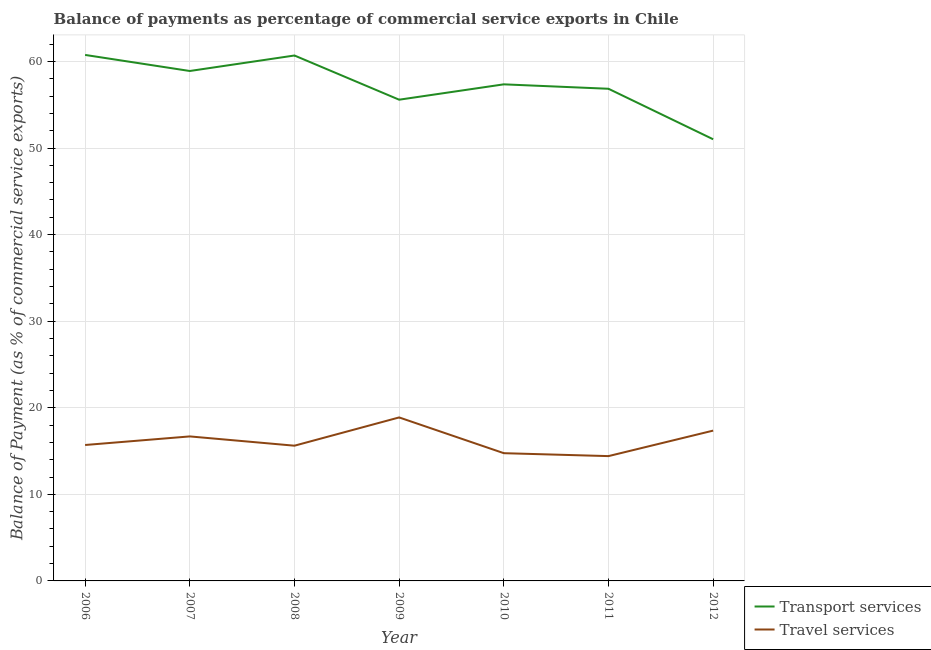What is the balance of payments of travel services in 2007?
Your answer should be very brief. 16.69. Across all years, what is the maximum balance of payments of travel services?
Provide a short and direct response. 18.88. Across all years, what is the minimum balance of payments of travel services?
Your response must be concise. 14.42. What is the total balance of payments of travel services in the graph?
Keep it short and to the point. 113.42. What is the difference between the balance of payments of travel services in 2006 and that in 2010?
Your response must be concise. 0.95. What is the difference between the balance of payments of transport services in 2007 and the balance of payments of travel services in 2009?
Your answer should be very brief. 40.01. What is the average balance of payments of travel services per year?
Keep it short and to the point. 16.2. In the year 2011, what is the difference between the balance of payments of travel services and balance of payments of transport services?
Offer a very short reply. -42.43. What is the ratio of the balance of payments of transport services in 2008 to that in 2011?
Offer a very short reply. 1.07. What is the difference between the highest and the second highest balance of payments of transport services?
Your answer should be compact. 0.07. What is the difference between the highest and the lowest balance of payments of transport services?
Offer a very short reply. 9.74. In how many years, is the balance of payments of travel services greater than the average balance of payments of travel services taken over all years?
Provide a short and direct response. 3. Is the sum of the balance of payments of transport services in 2008 and 2011 greater than the maximum balance of payments of travel services across all years?
Offer a very short reply. Yes. Does the balance of payments of transport services monotonically increase over the years?
Give a very brief answer. No. Does the graph contain grids?
Your response must be concise. Yes. Where does the legend appear in the graph?
Keep it short and to the point. Bottom right. How many legend labels are there?
Your answer should be very brief. 2. What is the title of the graph?
Provide a succinct answer. Balance of payments as percentage of commercial service exports in Chile. Does "Private creditors" appear as one of the legend labels in the graph?
Your answer should be very brief. No. What is the label or title of the Y-axis?
Your answer should be compact. Balance of Payment (as % of commercial service exports). What is the Balance of Payment (as % of commercial service exports) of Transport services in 2006?
Keep it short and to the point. 60.75. What is the Balance of Payment (as % of commercial service exports) of Travel services in 2006?
Provide a succinct answer. 15.7. What is the Balance of Payment (as % of commercial service exports) in Transport services in 2007?
Offer a terse response. 58.9. What is the Balance of Payment (as % of commercial service exports) of Travel services in 2007?
Your answer should be very brief. 16.69. What is the Balance of Payment (as % of commercial service exports) in Transport services in 2008?
Keep it short and to the point. 60.69. What is the Balance of Payment (as % of commercial service exports) of Travel services in 2008?
Your answer should be very brief. 15.62. What is the Balance of Payment (as % of commercial service exports) of Transport services in 2009?
Offer a very short reply. 55.58. What is the Balance of Payment (as % of commercial service exports) in Travel services in 2009?
Ensure brevity in your answer.  18.88. What is the Balance of Payment (as % of commercial service exports) of Transport services in 2010?
Offer a very short reply. 57.36. What is the Balance of Payment (as % of commercial service exports) of Travel services in 2010?
Make the answer very short. 14.75. What is the Balance of Payment (as % of commercial service exports) in Transport services in 2011?
Provide a succinct answer. 56.84. What is the Balance of Payment (as % of commercial service exports) of Travel services in 2011?
Make the answer very short. 14.42. What is the Balance of Payment (as % of commercial service exports) of Transport services in 2012?
Give a very brief answer. 51.01. What is the Balance of Payment (as % of commercial service exports) of Travel services in 2012?
Keep it short and to the point. 17.36. Across all years, what is the maximum Balance of Payment (as % of commercial service exports) of Transport services?
Offer a terse response. 60.75. Across all years, what is the maximum Balance of Payment (as % of commercial service exports) of Travel services?
Ensure brevity in your answer.  18.88. Across all years, what is the minimum Balance of Payment (as % of commercial service exports) of Transport services?
Ensure brevity in your answer.  51.01. Across all years, what is the minimum Balance of Payment (as % of commercial service exports) in Travel services?
Offer a terse response. 14.42. What is the total Balance of Payment (as % of commercial service exports) in Transport services in the graph?
Provide a succinct answer. 401.13. What is the total Balance of Payment (as % of commercial service exports) in Travel services in the graph?
Make the answer very short. 113.42. What is the difference between the Balance of Payment (as % of commercial service exports) of Transport services in 2006 and that in 2007?
Provide a short and direct response. 1.85. What is the difference between the Balance of Payment (as % of commercial service exports) in Travel services in 2006 and that in 2007?
Your answer should be compact. -0.99. What is the difference between the Balance of Payment (as % of commercial service exports) of Transport services in 2006 and that in 2008?
Provide a succinct answer. 0.07. What is the difference between the Balance of Payment (as % of commercial service exports) in Travel services in 2006 and that in 2008?
Offer a very short reply. 0.08. What is the difference between the Balance of Payment (as % of commercial service exports) in Transport services in 2006 and that in 2009?
Provide a short and direct response. 5.17. What is the difference between the Balance of Payment (as % of commercial service exports) of Travel services in 2006 and that in 2009?
Offer a very short reply. -3.18. What is the difference between the Balance of Payment (as % of commercial service exports) of Transport services in 2006 and that in 2010?
Ensure brevity in your answer.  3.4. What is the difference between the Balance of Payment (as % of commercial service exports) of Travel services in 2006 and that in 2010?
Keep it short and to the point. 0.95. What is the difference between the Balance of Payment (as % of commercial service exports) of Transport services in 2006 and that in 2011?
Ensure brevity in your answer.  3.91. What is the difference between the Balance of Payment (as % of commercial service exports) in Travel services in 2006 and that in 2011?
Ensure brevity in your answer.  1.28. What is the difference between the Balance of Payment (as % of commercial service exports) of Transport services in 2006 and that in 2012?
Your answer should be very brief. 9.74. What is the difference between the Balance of Payment (as % of commercial service exports) in Travel services in 2006 and that in 2012?
Your answer should be compact. -1.66. What is the difference between the Balance of Payment (as % of commercial service exports) in Transport services in 2007 and that in 2008?
Your answer should be very brief. -1.79. What is the difference between the Balance of Payment (as % of commercial service exports) of Travel services in 2007 and that in 2008?
Provide a succinct answer. 1.07. What is the difference between the Balance of Payment (as % of commercial service exports) in Transport services in 2007 and that in 2009?
Ensure brevity in your answer.  3.32. What is the difference between the Balance of Payment (as % of commercial service exports) in Travel services in 2007 and that in 2009?
Your answer should be very brief. -2.19. What is the difference between the Balance of Payment (as % of commercial service exports) in Transport services in 2007 and that in 2010?
Your answer should be compact. 1.54. What is the difference between the Balance of Payment (as % of commercial service exports) in Travel services in 2007 and that in 2010?
Ensure brevity in your answer.  1.94. What is the difference between the Balance of Payment (as % of commercial service exports) in Transport services in 2007 and that in 2011?
Provide a short and direct response. 2.05. What is the difference between the Balance of Payment (as % of commercial service exports) of Travel services in 2007 and that in 2011?
Your response must be concise. 2.27. What is the difference between the Balance of Payment (as % of commercial service exports) of Transport services in 2007 and that in 2012?
Make the answer very short. 7.89. What is the difference between the Balance of Payment (as % of commercial service exports) in Travel services in 2007 and that in 2012?
Ensure brevity in your answer.  -0.67. What is the difference between the Balance of Payment (as % of commercial service exports) of Transport services in 2008 and that in 2009?
Your answer should be very brief. 5.1. What is the difference between the Balance of Payment (as % of commercial service exports) of Travel services in 2008 and that in 2009?
Give a very brief answer. -3.26. What is the difference between the Balance of Payment (as % of commercial service exports) of Transport services in 2008 and that in 2010?
Make the answer very short. 3.33. What is the difference between the Balance of Payment (as % of commercial service exports) of Travel services in 2008 and that in 2010?
Make the answer very short. 0.87. What is the difference between the Balance of Payment (as % of commercial service exports) in Transport services in 2008 and that in 2011?
Provide a short and direct response. 3.84. What is the difference between the Balance of Payment (as % of commercial service exports) of Travel services in 2008 and that in 2011?
Provide a short and direct response. 1.2. What is the difference between the Balance of Payment (as % of commercial service exports) of Transport services in 2008 and that in 2012?
Give a very brief answer. 9.68. What is the difference between the Balance of Payment (as % of commercial service exports) of Travel services in 2008 and that in 2012?
Give a very brief answer. -1.74. What is the difference between the Balance of Payment (as % of commercial service exports) in Transport services in 2009 and that in 2010?
Make the answer very short. -1.77. What is the difference between the Balance of Payment (as % of commercial service exports) in Travel services in 2009 and that in 2010?
Ensure brevity in your answer.  4.13. What is the difference between the Balance of Payment (as % of commercial service exports) of Transport services in 2009 and that in 2011?
Keep it short and to the point. -1.26. What is the difference between the Balance of Payment (as % of commercial service exports) in Travel services in 2009 and that in 2011?
Offer a very short reply. 4.47. What is the difference between the Balance of Payment (as % of commercial service exports) in Transport services in 2009 and that in 2012?
Offer a terse response. 4.57. What is the difference between the Balance of Payment (as % of commercial service exports) in Travel services in 2009 and that in 2012?
Your answer should be compact. 1.52. What is the difference between the Balance of Payment (as % of commercial service exports) of Transport services in 2010 and that in 2011?
Your answer should be very brief. 0.51. What is the difference between the Balance of Payment (as % of commercial service exports) in Travel services in 2010 and that in 2011?
Make the answer very short. 0.34. What is the difference between the Balance of Payment (as % of commercial service exports) of Transport services in 2010 and that in 2012?
Make the answer very short. 6.35. What is the difference between the Balance of Payment (as % of commercial service exports) in Travel services in 2010 and that in 2012?
Ensure brevity in your answer.  -2.61. What is the difference between the Balance of Payment (as % of commercial service exports) of Transport services in 2011 and that in 2012?
Offer a terse response. 5.83. What is the difference between the Balance of Payment (as % of commercial service exports) of Travel services in 2011 and that in 2012?
Your answer should be very brief. -2.94. What is the difference between the Balance of Payment (as % of commercial service exports) of Transport services in 2006 and the Balance of Payment (as % of commercial service exports) of Travel services in 2007?
Give a very brief answer. 44.06. What is the difference between the Balance of Payment (as % of commercial service exports) of Transport services in 2006 and the Balance of Payment (as % of commercial service exports) of Travel services in 2008?
Offer a terse response. 45.13. What is the difference between the Balance of Payment (as % of commercial service exports) in Transport services in 2006 and the Balance of Payment (as % of commercial service exports) in Travel services in 2009?
Your response must be concise. 41.87. What is the difference between the Balance of Payment (as % of commercial service exports) in Transport services in 2006 and the Balance of Payment (as % of commercial service exports) in Travel services in 2010?
Ensure brevity in your answer.  46. What is the difference between the Balance of Payment (as % of commercial service exports) of Transport services in 2006 and the Balance of Payment (as % of commercial service exports) of Travel services in 2011?
Your answer should be compact. 46.34. What is the difference between the Balance of Payment (as % of commercial service exports) in Transport services in 2006 and the Balance of Payment (as % of commercial service exports) in Travel services in 2012?
Provide a succinct answer. 43.39. What is the difference between the Balance of Payment (as % of commercial service exports) of Transport services in 2007 and the Balance of Payment (as % of commercial service exports) of Travel services in 2008?
Your answer should be compact. 43.28. What is the difference between the Balance of Payment (as % of commercial service exports) in Transport services in 2007 and the Balance of Payment (as % of commercial service exports) in Travel services in 2009?
Offer a terse response. 40.01. What is the difference between the Balance of Payment (as % of commercial service exports) of Transport services in 2007 and the Balance of Payment (as % of commercial service exports) of Travel services in 2010?
Make the answer very short. 44.14. What is the difference between the Balance of Payment (as % of commercial service exports) of Transport services in 2007 and the Balance of Payment (as % of commercial service exports) of Travel services in 2011?
Ensure brevity in your answer.  44.48. What is the difference between the Balance of Payment (as % of commercial service exports) of Transport services in 2007 and the Balance of Payment (as % of commercial service exports) of Travel services in 2012?
Your answer should be compact. 41.54. What is the difference between the Balance of Payment (as % of commercial service exports) in Transport services in 2008 and the Balance of Payment (as % of commercial service exports) in Travel services in 2009?
Offer a very short reply. 41.8. What is the difference between the Balance of Payment (as % of commercial service exports) of Transport services in 2008 and the Balance of Payment (as % of commercial service exports) of Travel services in 2010?
Provide a short and direct response. 45.93. What is the difference between the Balance of Payment (as % of commercial service exports) of Transport services in 2008 and the Balance of Payment (as % of commercial service exports) of Travel services in 2011?
Your answer should be very brief. 46.27. What is the difference between the Balance of Payment (as % of commercial service exports) of Transport services in 2008 and the Balance of Payment (as % of commercial service exports) of Travel services in 2012?
Offer a very short reply. 43.33. What is the difference between the Balance of Payment (as % of commercial service exports) in Transport services in 2009 and the Balance of Payment (as % of commercial service exports) in Travel services in 2010?
Your answer should be very brief. 40.83. What is the difference between the Balance of Payment (as % of commercial service exports) of Transport services in 2009 and the Balance of Payment (as % of commercial service exports) of Travel services in 2011?
Offer a terse response. 41.17. What is the difference between the Balance of Payment (as % of commercial service exports) of Transport services in 2009 and the Balance of Payment (as % of commercial service exports) of Travel services in 2012?
Make the answer very short. 38.22. What is the difference between the Balance of Payment (as % of commercial service exports) of Transport services in 2010 and the Balance of Payment (as % of commercial service exports) of Travel services in 2011?
Offer a very short reply. 42.94. What is the difference between the Balance of Payment (as % of commercial service exports) in Transport services in 2010 and the Balance of Payment (as % of commercial service exports) in Travel services in 2012?
Offer a terse response. 39.99. What is the difference between the Balance of Payment (as % of commercial service exports) of Transport services in 2011 and the Balance of Payment (as % of commercial service exports) of Travel services in 2012?
Provide a succinct answer. 39.48. What is the average Balance of Payment (as % of commercial service exports) of Transport services per year?
Your answer should be compact. 57.3. What is the average Balance of Payment (as % of commercial service exports) of Travel services per year?
Provide a short and direct response. 16.2. In the year 2006, what is the difference between the Balance of Payment (as % of commercial service exports) in Transport services and Balance of Payment (as % of commercial service exports) in Travel services?
Ensure brevity in your answer.  45.05. In the year 2007, what is the difference between the Balance of Payment (as % of commercial service exports) in Transport services and Balance of Payment (as % of commercial service exports) in Travel services?
Ensure brevity in your answer.  42.21. In the year 2008, what is the difference between the Balance of Payment (as % of commercial service exports) of Transport services and Balance of Payment (as % of commercial service exports) of Travel services?
Offer a very short reply. 45.07. In the year 2009, what is the difference between the Balance of Payment (as % of commercial service exports) of Transport services and Balance of Payment (as % of commercial service exports) of Travel services?
Your answer should be very brief. 36.7. In the year 2010, what is the difference between the Balance of Payment (as % of commercial service exports) in Transport services and Balance of Payment (as % of commercial service exports) in Travel services?
Give a very brief answer. 42.6. In the year 2011, what is the difference between the Balance of Payment (as % of commercial service exports) in Transport services and Balance of Payment (as % of commercial service exports) in Travel services?
Give a very brief answer. 42.43. In the year 2012, what is the difference between the Balance of Payment (as % of commercial service exports) in Transport services and Balance of Payment (as % of commercial service exports) in Travel services?
Offer a very short reply. 33.65. What is the ratio of the Balance of Payment (as % of commercial service exports) in Transport services in 2006 to that in 2007?
Offer a very short reply. 1.03. What is the ratio of the Balance of Payment (as % of commercial service exports) of Travel services in 2006 to that in 2007?
Ensure brevity in your answer.  0.94. What is the ratio of the Balance of Payment (as % of commercial service exports) in Transport services in 2006 to that in 2008?
Give a very brief answer. 1. What is the ratio of the Balance of Payment (as % of commercial service exports) in Transport services in 2006 to that in 2009?
Your answer should be very brief. 1.09. What is the ratio of the Balance of Payment (as % of commercial service exports) of Travel services in 2006 to that in 2009?
Provide a short and direct response. 0.83. What is the ratio of the Balance of Payment (as % of commercial service exports) in Transport services in 2006 to that in 2010?
Give a very brief answer. 1.06. What is the ratio of the Balance of Payment (as % of commercial service exports) of Travel services in 2006 to that in 2010?
Your answer should be compact. 1.06. What is the ratio of the Balance of Payment (as % of commercial service exports) in Transport services in 2006 to that in 2011?
Your answer should be compact. 1.07. What is the ratio of the Balance of Payment (as % of commercial service exports) in Travel services in 2006 to that in 2011?
Your answer should be compact. 1.09. What is the ratio of the Balance of Payment (as % of commercial service exports) in Transport services in 2006 to that in 2012?
Your answer should be very brief. 1.19. What is the ratio of the Balance of Payment (as % of commercial service exports) of Travel services in 2006 to that in 2012?
Make the answer very short. 0.9. What is the ratio of the Balance of Payment (as % of commercial service exports) of Transport services in 2007 to that in 2008?
Your response must be concise. 0.97. What is the ratio of the Balance of Payment (as % of commercial service exports) in Travel services in 2007 to that in 2008?
Give a very brief answer. 1.07. What is the ratio of the Balance of Payment (as % of commercial service exports) of Transport services in 2007 to that in 2009?
Provide a succinct answer. 1.06. What is the ratio of the Balance of Payment (as % of commercial service exports) in Travel services in 2007 to that in 2009?
Offer a very short reply. 0.88. What is the ratio of the Balance of Payment (as % of commercial service exports) in Transport services in 2007 to that in 2010?
Your answer should be compact. 1.03. What is the ratio of the Balance of Payment (as % of commercial service exports) in Travel services in 2007 to that in 2010?
Offer a terse response. 1.13. What is the ratio of the Balance of Payment (as % of commercial service exports) in Transport services in 2007 to that in 2011?
Make the answer very short. 1.04. What is the ratio of the Balance of Payment (as % of commercial service exports) of Travel services in 2007 to that in 2011?
Your response must be concise. 1.16. What is the ratio of the Balance of Payment (as % of commercial service exports) of Transport services in 2007 to that in 2012?
Give a very brief answer. 1.15. What is the ratio of the Balance of Payment (as % of commercial service exports) in Travel services in 2007 to that in 2012?
Offer a terse response. 0.96. What is the ratio of the Balance of Payment (as % of commercial service exports) in Transport services in 2008 to that in 2009?
Provide a short and direct response. 1.09. What is the ratio of the Balance of Payment (as % of commercial service exports) in Travel services in 2008 to that in 2009?
Ensure brevity in your answer.  0.83. What is the ratio of the Balance of Payment (as % of commercial service exports) of Transport services in 2008 to that in 2010?
Your answer should be compact. 1.06. What is the ratio of the Balance of Payment (as % of commercial service exports) in Travel services in 2008 to that in 2010?
Keep it short and to the point. 1.06. What is the ratio of the Balance of Payment (as % of commercial service exports) of Transport services in 2008 to that in 2011?
Offer a very short reply. 1.07. What is the ratio of the Balance of Payment (as % of commercial service exports) of Travel services in 2008 to that in 2011?
Make the answer very short. 1.08. What is the ratio of the Balance of Payment (as % of commercial service exports) of Transport services in 2008 to that in 2012?
Offer a very short reply. 1.19. What is the ratio of the Balance of Payment (as % of commercial service exports) in Travel services in 2008 to that in 2012?
Your response must be concise. 0.9. What is the ratio of the Balance of Payment (as % of commercial service exports) of Transport services in 2009 to that in 2010?
Make the answer very short. 0.97. What is the ratio of the Balance of Payment (as % of commercial service exports) in Travel services in 2009 to that in 2010?
Offer a terse response. 1.28. What is the ratio of the Balance of Payment (as % of commercial service exports) of Transport services in 2009 to that in 2011?
Provide a succinct answer. 0.98. What is the ratio of the Balance of Payment (as % of commercial service exports) in Travel services in 2009 to that in 2011?
Offer a very short reply. 1.31. What is the ratio of the Balance of Payment (as % of commercial service exports) in Transport services in 2009 to that in 2012?
Keep it short and to the point. 1.09. What is the ratio of the Balance of Payment (as % of commercial service exports) in Travel services in 2009 to that in 2012?
Your answer should be very brief. 1.09. What is the ratio of the Balance of Payment (as % of commercial service exports) in Travel services in 2010 to that in 2011?
Your answer should be compact. 1.02. What is the ratio of the Balance of Payment (as % of commercial service exports) of Transport services in 2010 to that in 2012?
Ensure brevity in your answer.  1.12. What is the ratio of the Balance of Payment (as % of commercial service exports) in Travel services in 2010 to that in 2012?
Offer a terse response. 0.85. What is the ratio of the Balance of Payment (as % of commercial service exports) of Transport services in 2011 to that in 2012?
Your answer should be compact. 1.11. What is the ratio of the Balance of Payment (as % of commercial service exports) of Travel services in 2011 to that in 2012?
Keep it short and to the point. 0.83. What is the difference between the highest and the second highest Balance of Payment (as % of commercial service exports) in Transport services?
Your response must be concise. 0.07. What is the difference between the highest and the second highest Balance of Payment (as % of commercial service exports) of Travel services?
Keep it short and to the point. 1.52. What is the difference between the highest and the lowest Balance of Payment (as % of commercial service exports) in Transport services?
Provide a short and direct response. 9.74. What is the difference between the highest and the lowest Balance of Payment (as % of commercial service exports) of Travel services?
Your answer should be compact. 4.47. 